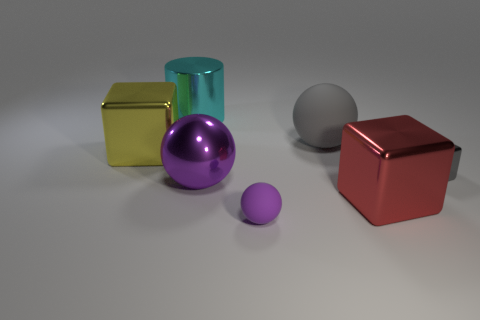Is the number of purple matte spheres that are behind the large gray rubber object greater than the number of purple shiny spheres that are in front of the large red metallic object?
Make the answer very short. No. How many other large cylinders are the same color as the big metallic cylinder?
Give a very brief answer. 0. There is a yellow cube that is made of the same material as the large purple ball; what size is it?
Make the answer very short. Large. How many things are either metallic things that are in front of the cyan object or metallic objects?
Keep it short and to the point. 5. There is a matte object in front of the gray ball; is it the same color as the large matte sphere?
Ensure brevity in your answer.  No. What is the size of the red metal thing that is the same shape as the yellow thing?
Provide a short and direct response. Large. There is a matte sphere behind the metal thing right of the big block that is right of the big purple ball; what is its color?
Give a very brief answer. Gray. Is the material of the cyan cylinder the same as the small purple thing?
Your answer should be very brief. No. There is a sphere that is on the left side of the rubber ball that is in front of the large red metal block; is there a cube left of it?
Your response must be concise. Yes. Is the metallic cylinder the same color as the small block?
Offer a terse response. No. 